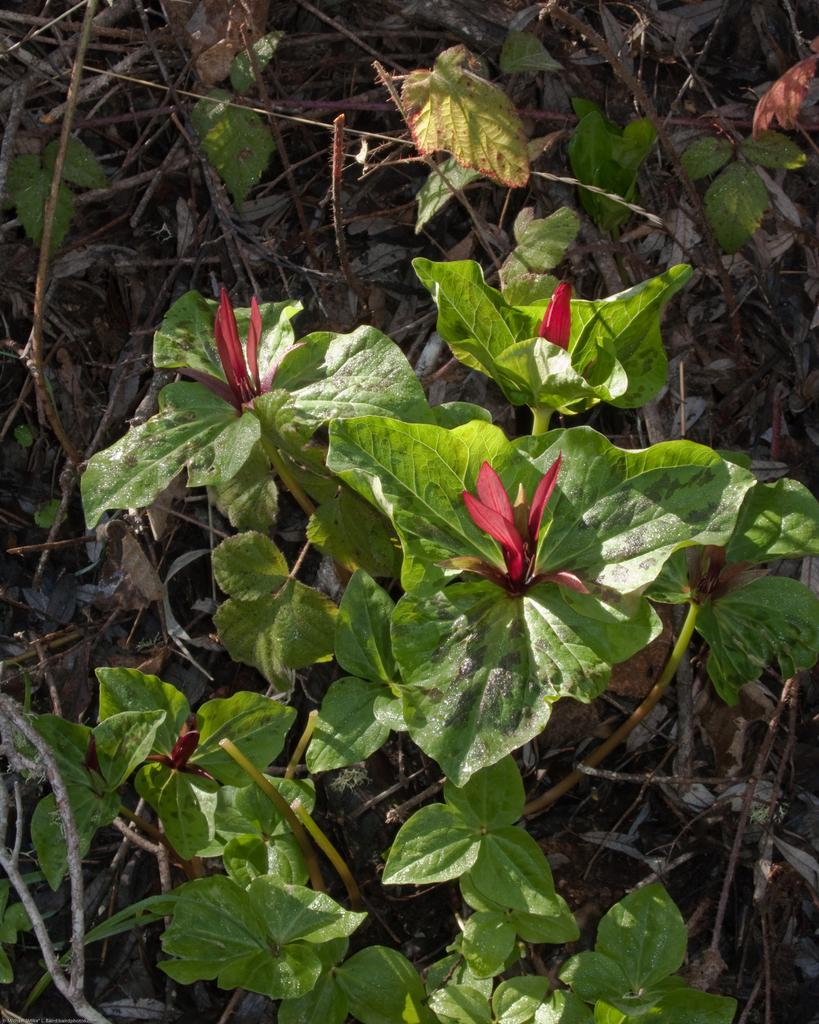What type of living organisms can be seen in the image? Plants can be seen in the image. What specific features can be observed on the plants? The plants have flowers and leaves. How does the page in the image affect the growth of the plants? There is no page present in the image, as it features plants with flowers and leaves. 